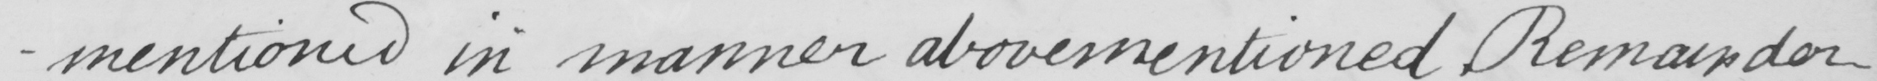What text is written in this handwritten line? -mentioned  in manner abovementioned . Remainder 